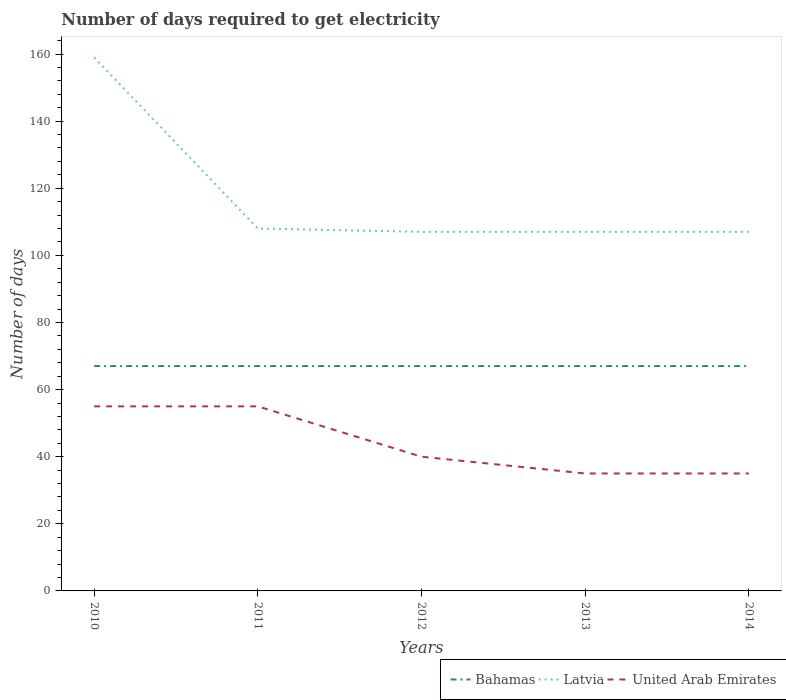Does the line corresponding to United Arab Emirates intersect with the line corresponding to Latvia?
Keep it short and to the point. No. Across all years, what is the maximum number of days required to get electricity in in Latvia?
Give a very brief answer. 107. What is the total number of days required to get electricity in in Latvia in the graph?
Your response must be concise. 0. What is the difference between the highest and the second highest number of days required to get electricity in in United Arab Emirates?
Your answer should be very brief. 20. Is the number of days required to get electricity in in Latvia strictly greater than the number of days required to get electricity in in Bahamas over the years?
Your answer should be very brief. No. How many years are there in the graph?
Your answer should be compact. 5. What is the difference between two consecutive major ticks on the Y-axis?
Provide a short and direct response. 20. Are the values on the major ticks of Y-axis written in scientific E-notation?
Offer a very short reply. No. Does the graph contain grids?
Give a very brief answer. No. How are the legend labels stacked?
Your answer should be compact. Horizontal. What is the title of the graph?
Your answer should be compact. Number of days required to get electricity. Does "Antigua and Barbuda" appear as one of the legend labels in the graph?
Provide a short and direct response. No. What is the label or title of the Y-axis?
Your answer should be compact. Number of days. What is the Number of days in Latvia in 2010?
Ensure brevity in your answer.  159. What is the Number of days of United Arab Emirates in 2010?
Ensure brevity in your answer.  55. What is the Number of days in Latvia in 2011?
Your answer should be very brief. 108. What is the Number of days in United Arab Emirates in 2011?
Keep it short and to the point. 55. What is the Number of days of Latvia in 2012?
Your answer should be very brief. 107. What is the Number of days of United Arab Emirates in 2012?
Provide a succinct answer. 40. What is the Number of days in Bahamas in 2013?
Give a very brief answer. 67. What is the Number of days in Latvia in 2013?
Give a very brief answer. 107. What is the Number of days of Latvia in 2014?
Give a very brief answer. 107. What is the Number of days of United Arab Emirates in 2014?
Keep it short and to the point. 35. Across all years, what is the maximum Number of days of Latvia?
Your answer should be very brief. 159. Across all years, what is the minimum Number of days of Latvia?
Offer a very short reply. 107. Across all years, what is the minimum Number of days of United Arab Emirates?
Your answer should be compact. 35. What is the total Number of days of Bahamas in the graph?
Give a very brief answer. 335. What is the total Number of days of Latvia in the graph?
Your answer should be compact. 588. What is the total Number of days of United Arab Emirates in the graph?
Give a very brief answer. 220. What is the difference between the Number of days of Latvia in 2010 and that in 2011?
Provide a succinct answer. 51. What is the difference between the Number of days in Bahamas in 2010 and that in 2012?
Ensure brevity in your answer.  0. What is the difference between the Number of days in Bahamas in 2010 and that in 2013?
Your response must be concise. 0. What is the difference between the Number of days of Latvia in 2010 and that in 2013?
Keep it short and to the point. 52. What is the difference between the Number of days of Latvia in 2011 and that in 2012?
Offer a very short reply. 1. What is the difference between the Number of days in Latvia in 2011 and that in 2014?
Offer a terse response. 1. What is the difference between the Number of days in Bahamas in 2012 and that in 2013?
Your answer should be compact. 0. What is the difference between the Number of days of United Arab Emirates in 2012 and that in 2013?
Give a very brief answer. 5. What is the difference between the Number of days in Bahamas in 2012 and that in 2014?
Give a very brief answer. 0. What is the difference between the Number of days in Latvia in 2012 and that in 2014?
Make the answer very short. 0. What is the difference between the Number of days of United Arab Emirates in 2012 and that in 2014?
Ensure brevity in your answer.  5. What is the difference between the Number of days in Bahamas in 2013 and that in 2014?
Your answer should be compact. 0. What is the difference between the Number of days of Latvia in 2013 and that in 2014?
Provide a short and direct response. 0. What is the difference between the Number of days of United Arab Emirates in 2013 and that in 2014?
Provide a short and direct response. 0. What is the difference between the Number of days in Bahamas in 2010 and the Number of days in Latvia in 2011?
Give a very brief answer. -41. What is the difference between the Number of days of Latvia in 2010 and the Number of days of United Arab Emirates in 2011?
Your answer should be compact. 104. What is the difference between the Number of days of Bahamas in 2010 and the Number of days of United Arab Emirates in 2012?
Give a very brief answer. 27. What is the difference between the Number of days of Latvia in 2010 and the Number of days of United Arab Emirates in 2012?
Your response must be concise. 119. What is the difference between the Number of days in Latvia in 2010 and the Number of days in United Arab Emirates in 2013?
Ensure brevity in your answer.  124. What is the difference between the Number of days in Bahamas in 2010 and the Number of days in Latvia in 2014?
Offer a terse response. -40. What is the difference between the Number of days of Bahamas in 2010 and the Number of days of United Arab Emirates in 2014?
Keep it short and to the point. 32. What is the difference between the Number of days in Latvia in 2010 and the Number of days in United Arab Emirates in 2014?
Keep it short and to the point. 124. What is the difference between the Number of days in Bahamas in 2011 and the Number of days in Latvia in 2012?
Your answer should be compact. -40. What is the difference between the Number of days of Bahamas in 2012 and the Number of days of Latvia in 2013?
Offer a terse response. -40. What is the difference between the Number of days in Bahamas in 2012 and the Number of days in United Arab Emirates in 2014?
Your answer should be very brief. 32. What is the difference between the Number of days of Bahamas in 2013 and the Number of days of United Arab Emirates in 2014?
Your response must be concise. 32. What is the difference between the Number of days in Latvia in 2013 and the Number of days in United Arab Emirates in 2014?
Your response must be concise. 72. What is the average Number of days of Bahamas per year?
Offer a terse response. 67. What is the average Number of days in Latvia per year?
Your answer should be very brief. 117.6. In the year 2010, what is the difference between the Number of days of Bahamas and Number of days of Latvia?
Your response must be concise. -92. In the year 2010, what is the difference between the Number of days in Bahamas and Number of days in United Arab Emirates?
Give a very brief answer. 12. In the year 2010, what is the difference between the Number of days of Latvia and Number of days of United Arab Emirates?
Your response must be concise. 104. In the year 2011, what is the difference between the Number of days in Bahamas and Number of days in Latvia?
Your answer should be compact. -41. In the year 2011, what is the difference between the Number of days in Latvia and Number of days in United Arab Emirates?
Provide a succinct answer. 53. In the year 2012, what is the difference between the Number of days in Bahamas and Number of days in Latvia?
Your answer should be compact. -40. In the year 2012, what is the difference between the Number of days of Bahamas and Number of days of United Arab Emirates?
Your answer should be compact. 27. In the year 2012, what is the difference between the Number of days of Latvia and Number of days of United Arab Emirates?
Your answer should be compact. 67. In the year 2013, what is the difference between the Number of days of Bahamas and Number of days of United Arab Emirates?
Provide a succinct answer. 32. In the year 2014, what is the difference between the Number of days in Bahamas and Number of days in Latvia?
Make the answer very short. -40. In the year 2014, what is the difference between the Number of days in Latvia and Number of days in United Arab Emirates?
Ensure brevity in your answer.  72. What is the ratio of the Number of days of Bahamas in 2010 to that in 2011?
Your response must be concise. 1. What is the ratio of the Number of days in Latvia in 2010 to that in 2011?
Provide a short and direct response. 1.47. What is the ratio of the Number of days in Bahamas in 2010 to that in 2012?
Keep it short and to the point. 1. What is the ratio of the Number of days of Latvia in 2010 to that in 2012?
Offer a terse response. 1.49. What is the ratio of the Number of days of United Arab Emirates in 2010 to that in 2012?
Your answer should be very brief. 1.38. What is the ratio of the Number of days in Latvia in 2010 to that in 2013?
Give a very brief answer. 1.49. What is the ratio of the Number of days of United Arab Emirates in 2010 to that in 2013?
Make the answer very short. 1.57. What is the ratio of the Number of days in Latvia in 2010 to that in 2014?
Offer a terse response. 1.49. What is the ratio of the Number of days in United Arab Emirates in 2010 to that in 2014?
Keep it short and to the point. 1.57. What is the ratio of the Number of days of Bahamas in 2011 to that in 2012?
Provide a short and direct response. 1. What is the ratio of the Number of days of Latvia in 2011 to that in 2012?
Your response must be concise. 1.01. What is the ratio of the Number of days in United Arab Emirates in 2011 to that in 2012?
Your response must be concise. 1.38. What is the ratio of the Number of days of Bahamas in 2011 to that in 2013?
Keep it short and to the point. 1. What is the ratio of the Number of days of Latvia in 2011 to that in 2013?
Your response must be concise. 1.01. What is the ratio of the Number of days of United Arab Emirates in 2011 to that in 2013?
Ensure brevity in your answer.  1.57. What is the ratio of the Number of days of Latvia in 2011 to that in 2014?
Provide a succinct answer. 1.01. What is the ratio of the Number of days in United Arab Emirates in 2011 to that in 2014?
Your answer should be compact. 1.57. What is the ratio of the Number of days of United Arab Emirates in 2012 to that in 2013?
Make the answer very short. 1.14. What is the ratio of the Number of days of United Arab Emirates in 2012 to that in 2014?
Offer a very short reply. 1.14. What is the ratio of the Number of days of Latvia in 2013 to that in 2014?
Offer a very short reply. 1. What is the ratio of the Number of days of United Arab Emirates in 2013 to that in 2014?
Your answer should be compact. 1. What is the difference between the highest and the second highest Number of days of Bahamas?
Provide a succinct answer. 0. What is the difference between the highest and the second highest Number of days in United Arab Emirates?
Make the answer very short. 0. What is the difference between the highest and the lowest Number of days of Bahamas?
Your answer should be compact. 0. What is the difference between the highest and the lowest Number of days in Latvia?
Offer a very short reply. 52. What is the difference between the highest and the lowest Number of days in United Arab Emirates?
Your answer should be compact. 20. 